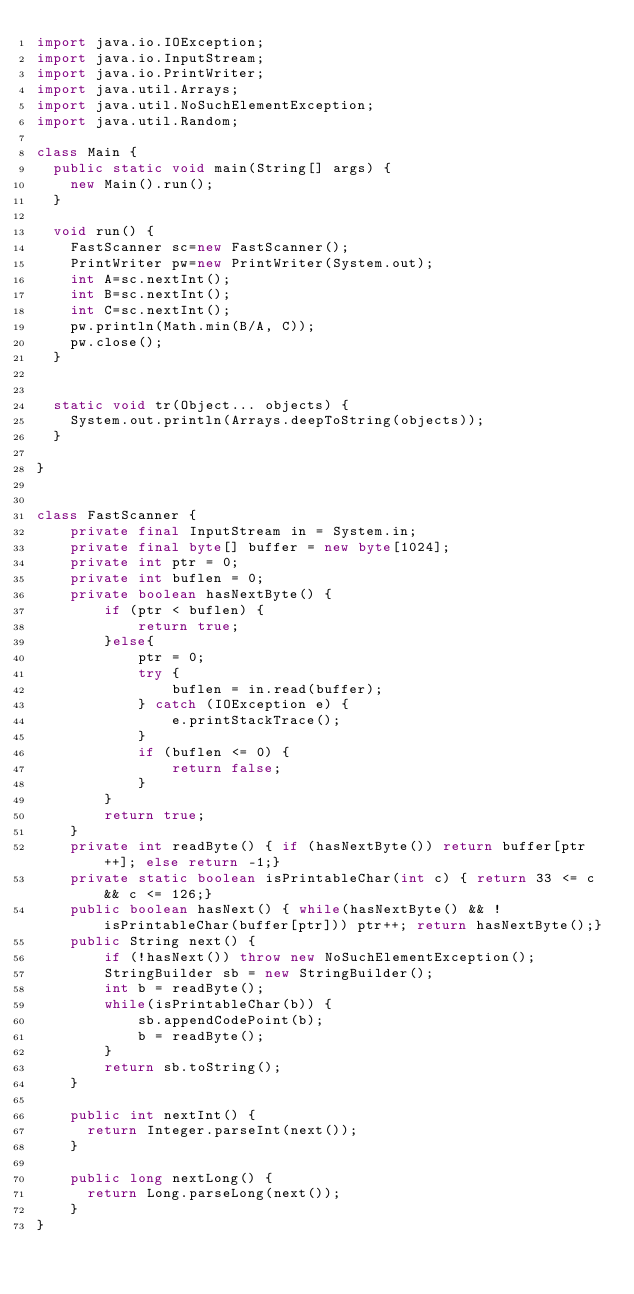<code> <loc_0><loc_0><loc_500><loc_500><_Java_>import java.io.IOException;
import java.io.InputStream;
import java.io.PrintWriter;
import java.util.Arrays;
import java.util.NoSuchElementException;
import java.util.Random;

class Main {
	public static void main(String[] args) {
		new Main().run();
	}
	
	void run() {
		FastScanner sc=new FastScanner();
		PrintWriter pw=new PrintWriter(System.out);
		int A=sc.nextInt();
		int B=sc.nextInt();
		int C=sc.nextInt();
		pw.println(Math.min(B/A, C));
		pw.close();
	}

	
	static void tr(Object... objects) {
		System.out.println(Arrays.deepToString(objects));
	}

}


class FastScanner {
    private final InputStream in = System.in;
    private final byte[] buffer = new byte[1024];
    private int ptr = 0;
    private int buflen = 0;
    private boolean hasNextByte() {
        if (ptr < buflen) {
            return true;
        }else{
            ptr = 0;
            try {
                buflen = in.read(buffer);
            } catch (IOException e) {
                e.printStackTrace();
            }
            if (buflen <= 0) {
                return false;
            }
        }
        return true;
    }
    private int readByte() { if (hasNextByte()) return buffer[ptr++]; else return -1;}
    private static boolean isPrintableChar(int c) { return 33 <= c && c <= 126;}
    public boolean hasNext() { while(hasNextByte() && !isPrintableChar(buffer[ptr])) ptr++; return hasNextByte();}
    public String next() {
        if (!hasNext()) throw new NoSuchElementException();
        StringBuilder sb = new StringBuilder();
        int b = readByte();
        while(isPrintableChar(b)) {
            sb.appendCodePoint(b);
            b = readByte();
        }
        return sb.toString();
    }

    public int nextInt() {
    	return Integer.parseInt(next());
    }
    
    public long nextLong() {
    	return Long.parseLong(next());
    }
}</code> 